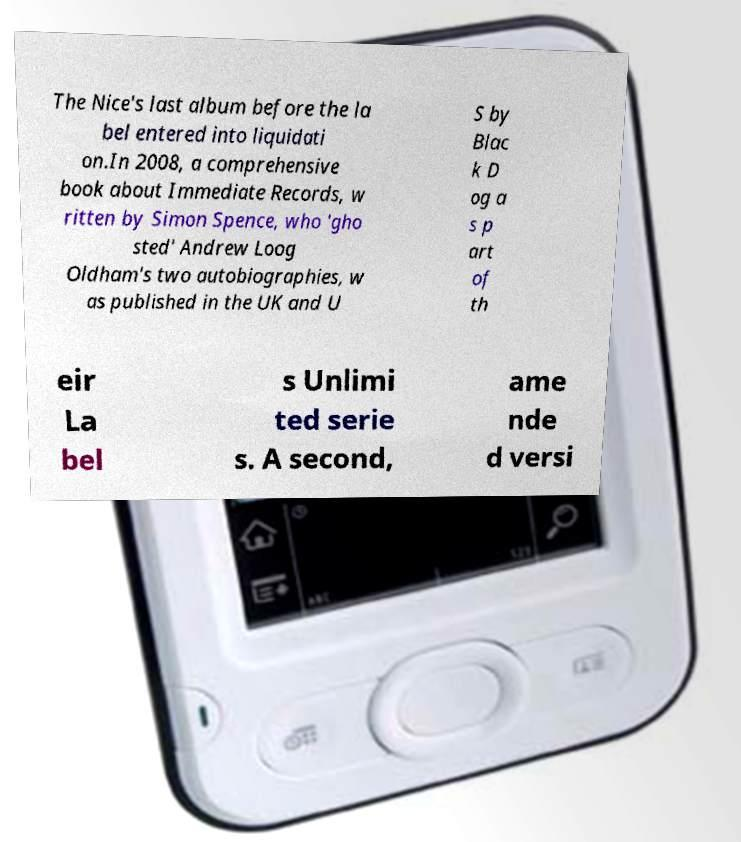Could you assist in decoding the text presented in this image and type it out clearly? The Nice's last album before the la bel entered into liquidati on.In 2008, a comprehensive book about Immediate Records, w ritten by Simon Spence, who 'gho sted' Andrew Loog Oldham's two autobiographies, w as published in the UK and U S by Blac k D og a s p art of th eir La bel s Unlimi ted serie s. A second, ame nde d versi 